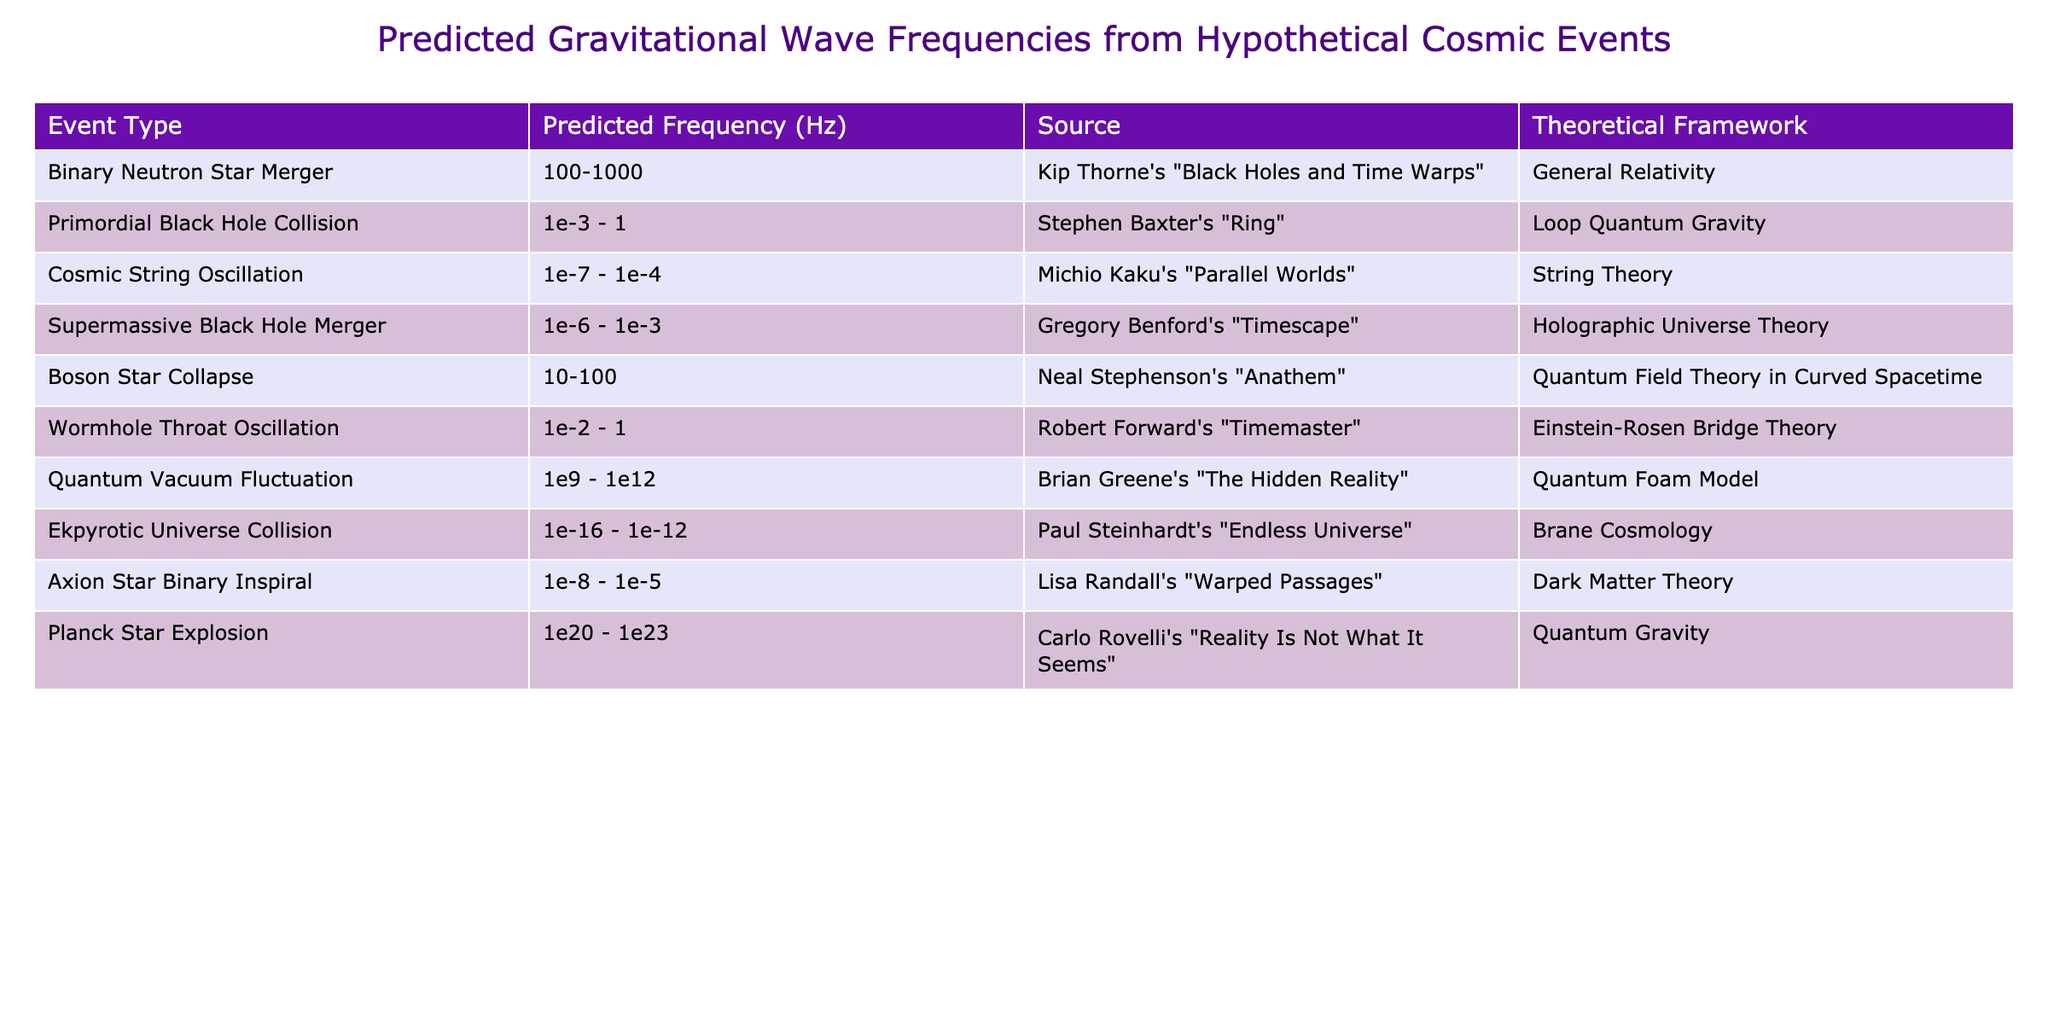What is the predicted frequency range for a Binary Neutron Star Merger? The table shows that the predicted frequency range for a Binary Neutron Star Merger is 100-1000 Hz.
Answer: 100-1000 Hz Which event type has the highest predicted frequency range? By examining the table, the predicted frequency range for Quantum Vacuum Fluctuation is from 1e9 to 1e12 Hz, which is the highest compared to other events listed.
Answer: Quantum Vacuum Fluctuation Is the predicted frequency range of the Primordial Black Hole Collision higher or lower than that of the Cosmic String Oscillation? The table indicates that the frequency range for Primordial Black Hole Collision (1e-3 - 1 Hz) is higher than that of Cosmic String Oscillation (1e-7 - 1e-4 Hz).
Answer: Higher What is the difference in the lower frequency bounds of the Boson Star Collapse and Wormhole Throat Oscillation? The lower bound for Boson Star Collapse is 10 Hz, and for Wormhole Throat Oscillation it is 1e-2 Hz (0.01 Hz). To find the difference, we convert 10 Hz to 1000 times smaller (10 - 0.01 = 9.99). Thus, the difference is significant, but in terms of magnitude, it is not numerically comparable without conversion. However, the significant difference in scientific significance is evident, as one is in the regular Hz range and the other in a much smaller range.
Answer: The difference is 9.99 Hz Which theoretical framework corresponds to the event type with the lowest upper frequency limit? The event type with the lowest upper limit is Ekpyrotic Universe Collision, which has an upper limit of 1e-12 Hz. This event corresponds to Brane Cosmology as detailed in the table.
Answer: Brane Cosmology How do the predicted frequency ranges of the Axion Star Binary Inspiral and Supermassive Black Hole Merger compare? The Axion Star Binary Inspiral has a predicted frequency range of 1e-8 - 1e-5 Hz and the Supermassive Black Hole Merger has a range of 1e-6 - 1e-3 Hz. To compare, the Axion range has both its bounds lower than those of the Supermassive range, indicating that the Axion Star event is generally at lower frequencies. Thus, Axion Star has lower frequency predictions overall.
Answer: Axion Star Binary Inspiral has lower frequencies Which event type, according to the table, predicts frequencies over 20 Hz? The table lists the Boson Star Collapse with a frequency range of 10-100 Hz, and also the Binary Neutron Star Merger with a range of 100-1000 Hz, indicating both events predict frequencies over 20 Hz.
Answer: Binary Neutron Star Merger and Boson Star Collapse 